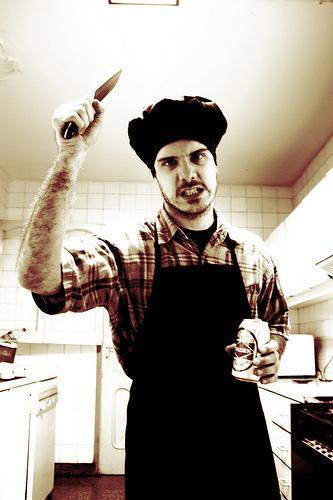How many knives is the man holding?
Give a very brief answer. 1. 